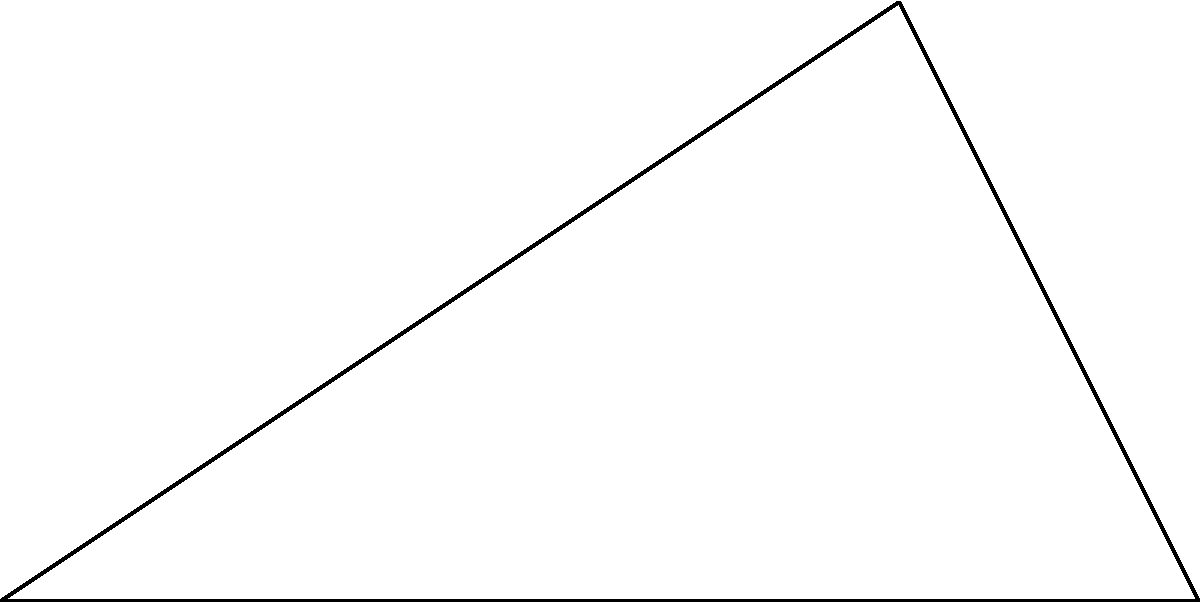As an investor evaluating offshore oil operations, you need to assess the distance between two rigs. Oil Rig A and Oil Rig C are connected by a straight line passing through Oil Rig B. The distance from Rig A to Rig B is 5 km, and from Rig B to Rig C is 4 km. If the angle between AB and BC is $90^\circ$, what is the direct distance between Rig A and Rig C? Round your answer to two decimal places. To solve this problem, we can use the Pythagorean theorem:

1) Let's denote the distance between Rig A and Rig C as $x$.

2) We know that:
   AB = 5 km
   BC = 4 km
   Angle ABC = $90^\circ$

3) Using the Pythagorean theorem:
   $x^2 = AB^2 + BC^2$

4) Substituting the known values:
   $x^2 = 5^2 + 4^2$

5) Simplify:
   $x^2 = 25 + 16 = 41$

6) Take the square root of both sides:
   $x = \sqrt{41}$

7) Calculate and round to two decimal places:
   $x \approx 6.40$ km

Therefore, the direct distance between Oil Rig A and Oil Rig C is approximately 6.40 km.
Answer: 6.40 km 